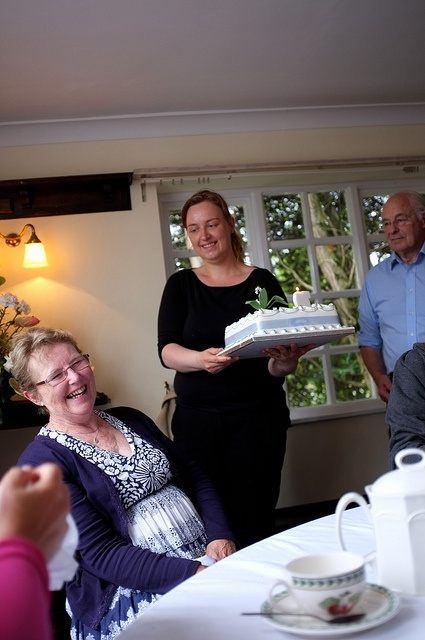Describe the objects in this image and their specific colors. I can see people in gray, black, navy, lavender, and lightpink tones, people in gray, black, brown, maroon, and lightgray tones, dining table in gray, lavender, and darkgray tones, people in gray, maroon, purple, and brown tones, and people in gray, maroon, and black tones in this image. 